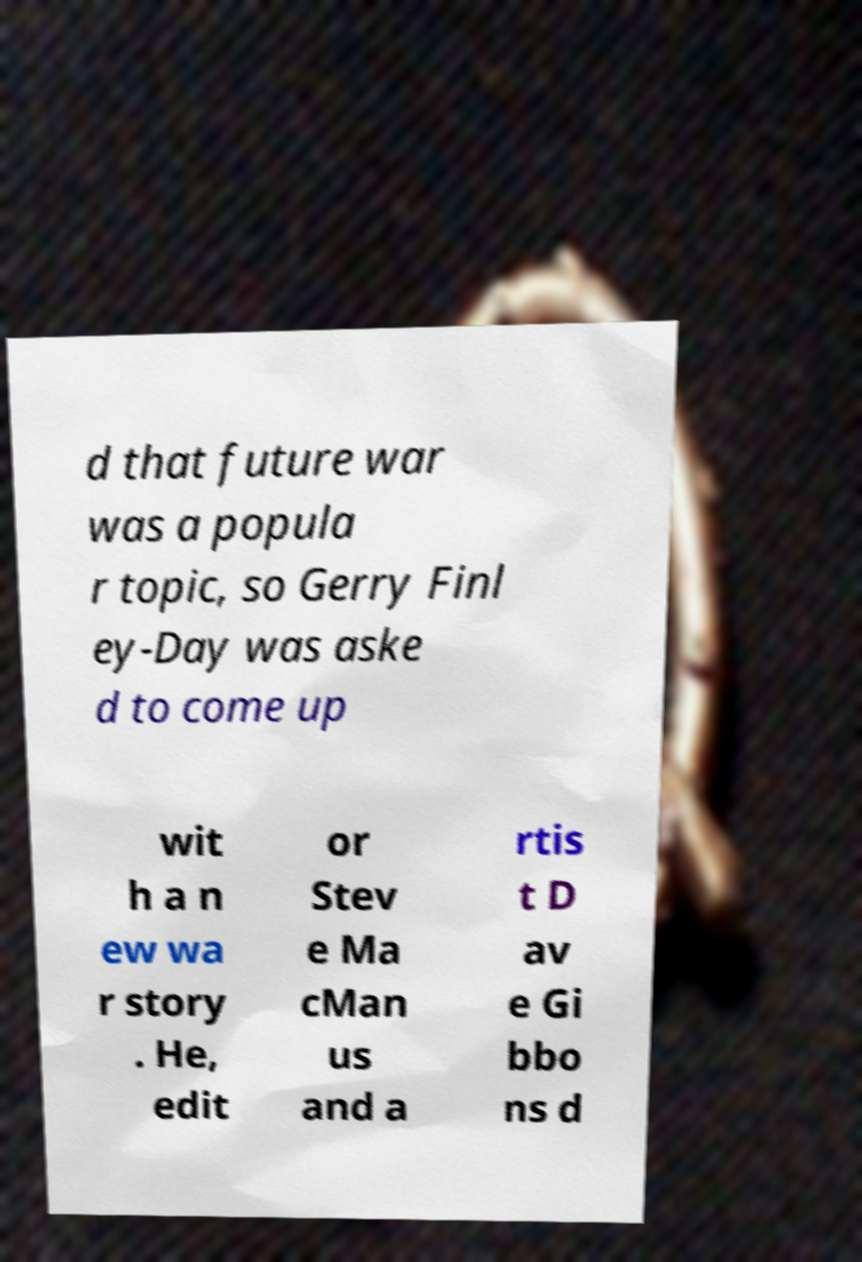Could you extract and type out the text from this image? d that future war was a popula r topic, so Gerry Finl ey-Day was aske d to come up wit h a n ew wa r story . He, edit or Stev e Ma cMan us and a rtis t D av e Gi bbo ns d 